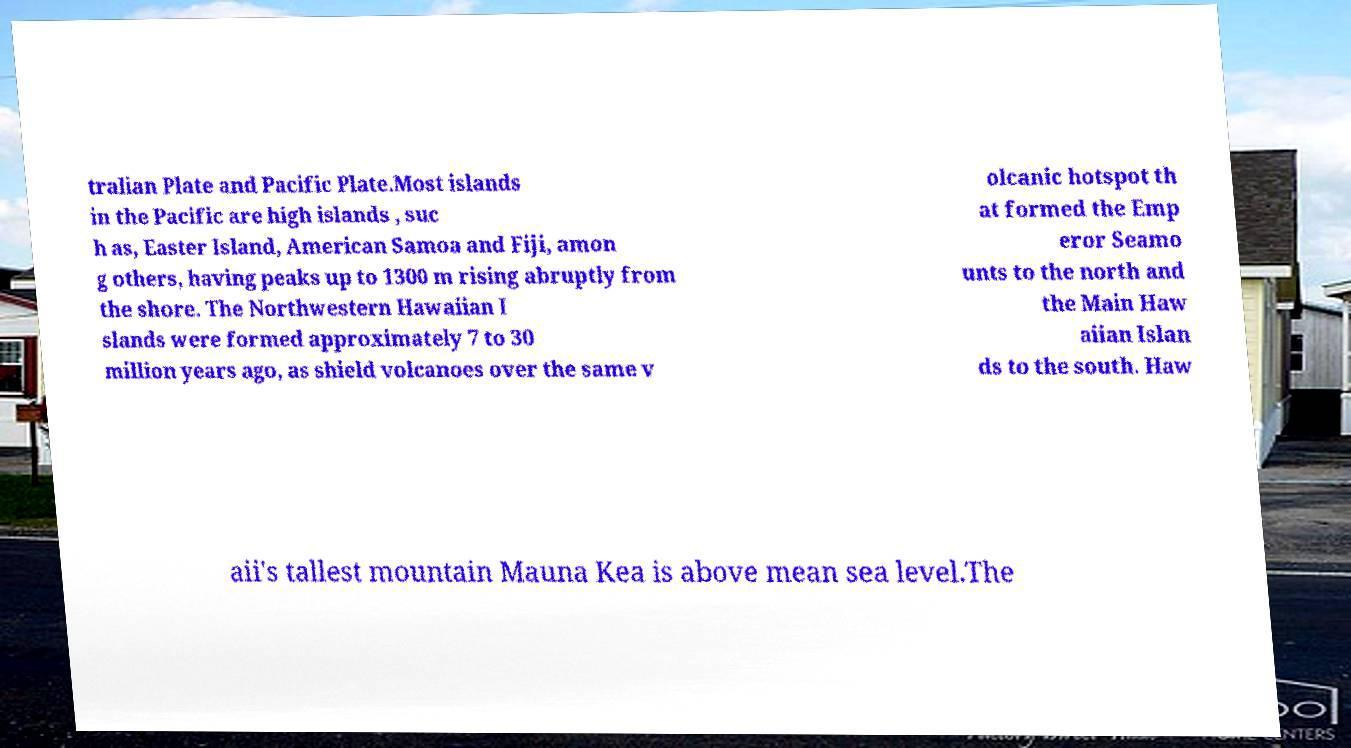Could you assist in decoding the text presented in this image and type it out clearly? tralian Plate and Pacific Plate.Most islands in the Pacific are high islands , suc h as, Easter Island, American Samoa and Fiji, amon g others, having peaks up to 1300 m rising abruptly from the shore. The Northwestern Hawaiian I slands were formed approximately 7 to 30 million years ago, as shield volcanoes over the same v olcanic hotspot th at formed the Emp eror Seamo unts to the north and the Main Haw aiian Islan ds to the south. Haw aii's tallest mountain Mauna Kea is above mean sea level.The 